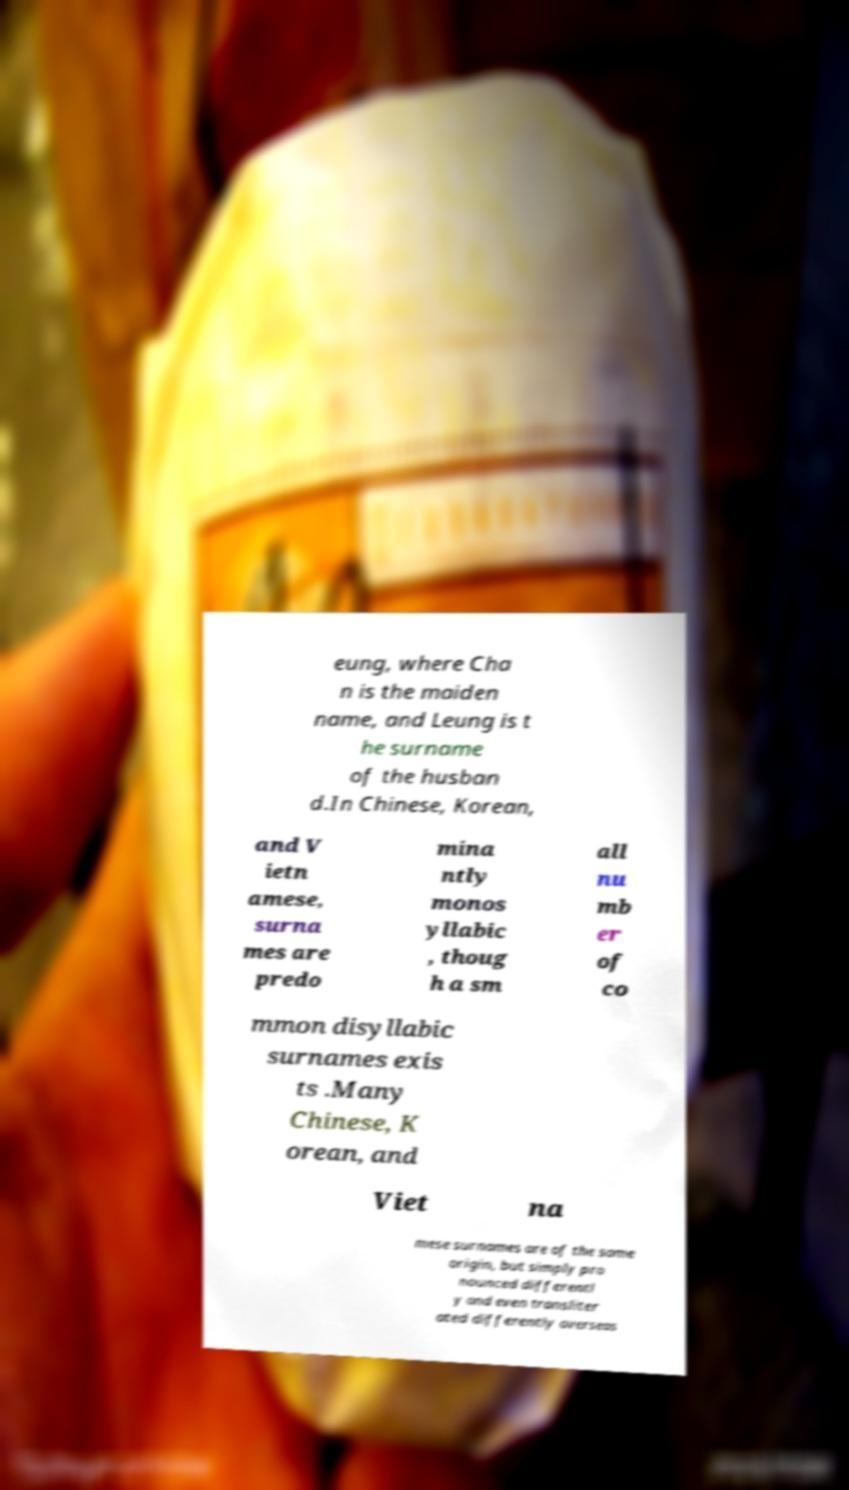There's text embedded in this image that I need extracted. Can you transcribe it verbatim? eung, where Cha n is the maiden name, and Leung is t he surname of the husban d.In Chinese, Korean, and V ietn amese, surna mes are predo mina ntly monos yllabic , thoug h a sm all nu mb er of co mmon disyllabic surnames exis ts .Many Chinese, K orean, and Viet na mese surnames are of the same origin, but simply pro nounced differentl y and even transliter ated differently overseas 